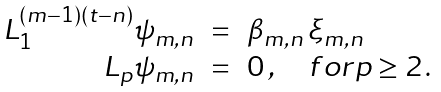<formula> <loc_0><loc_0><loc_500><loc_500>\begin{array} { r c l } { { L _ { 1 } ^ { ( m - 1 ) ( t - n ) } \psi _ { m , n } } } & { = } & { { \beta _ { m , n } \, \xi _ { m , n } \, } } \\ { { L _ { p } \psi _ { m , n } } } & { = } & { 0 \, , \quad f o r p \geq 2 \, . } \end{array}</formula> 